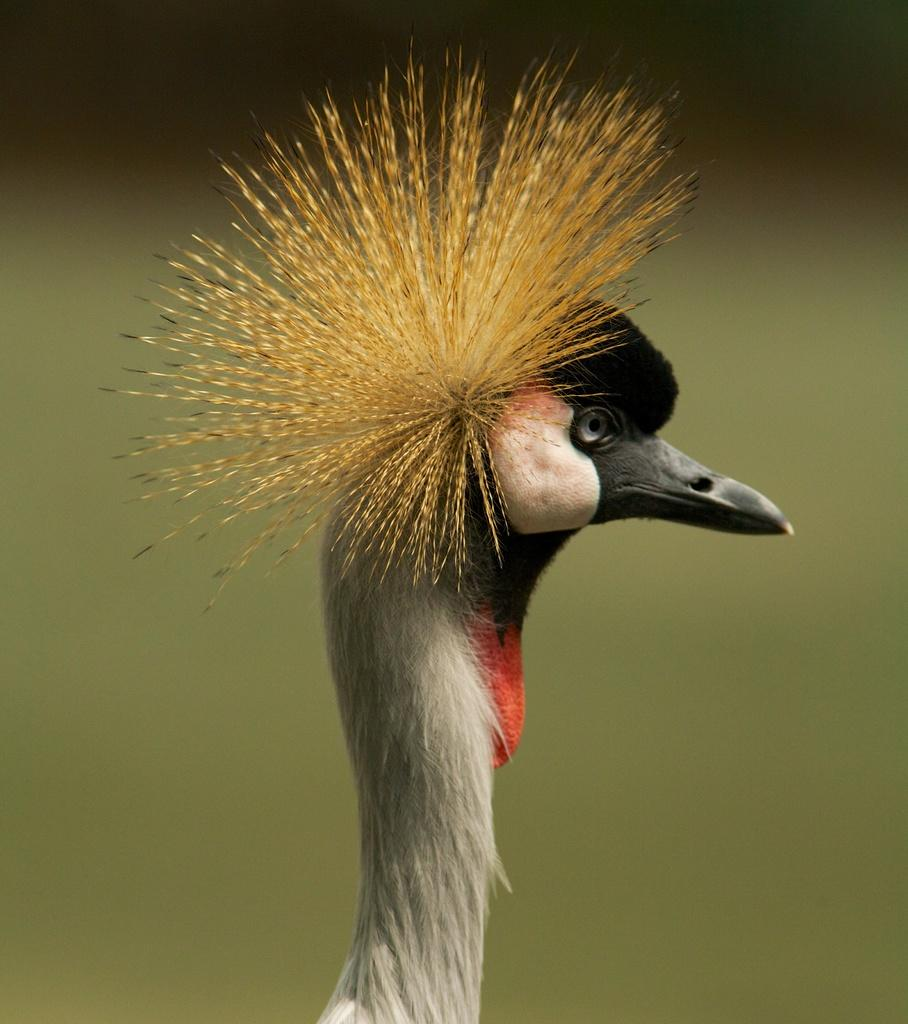What type of bird is featured in the image? There is a flightless bird in the picture. Can you describe any specific features of the bird? The bird has a long neck and a sharp beak. What color is the background of the image? The background of the image is green in color. Can you tell me how many actors are present in the image? There are no actors present in the image; it features a flightless bird with a long neck and a sharp beak against a green background. 